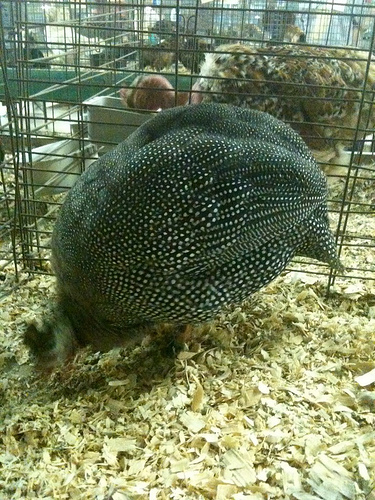<image>
Is the chicken in the coop? Yes. The chicken is contained within or inside the coop, showing a containment relationship. 